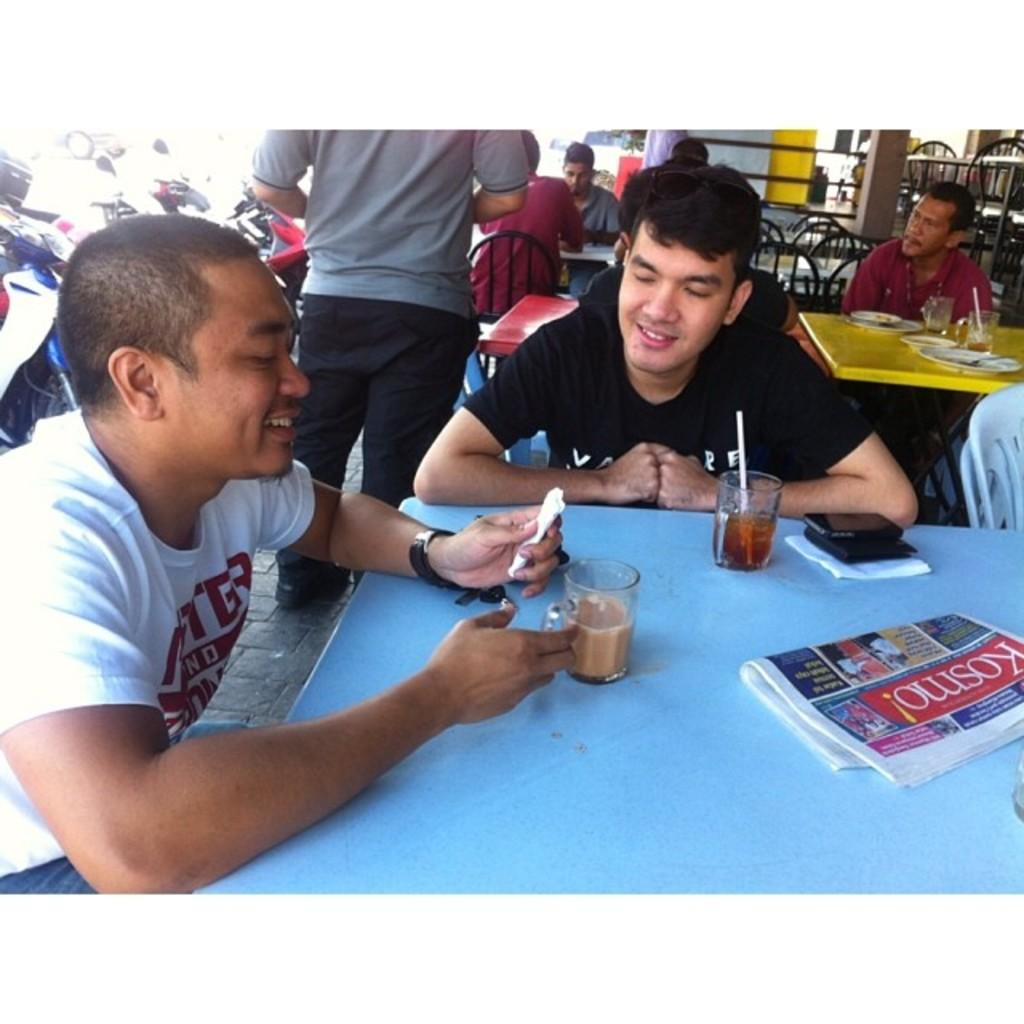What are the persons in the image doing? The persons in the image are sitting on chairs. What objects can be seen on the table in the image? There is a glass, a paper, a phone, and a drink on the table in the image. What is the purpose of the paper on the table? The purpose of the paper on the table is not specified in the image, but it could be for writing, reading, or other purposes. What can be seen in the background of the image? Vehicles are visible in the background of the image. What type of clover is growing on the table in the image? There is no clover present on the table in the image. What is the interest of the persons sitting on chairs in the image? The image does not provide information about the interests of the persons sitting on chairs. 